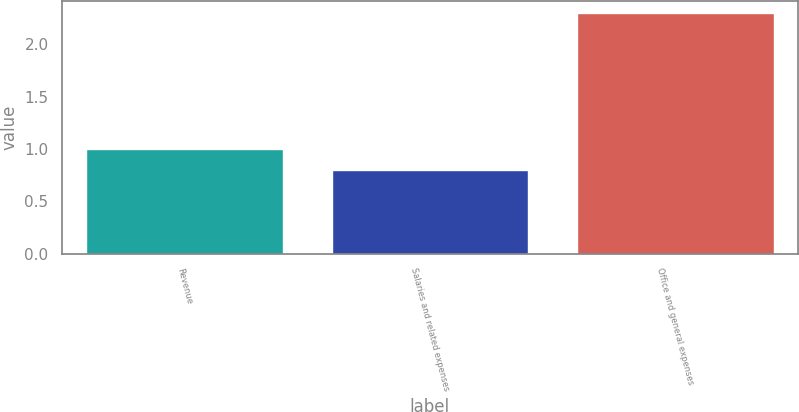<chart> <loc_0><loc_0><loc_500><loc_500><bar_chart><fcel>Revenue<fcel>Salaries and related expenses<fcel>Office and general expenses<nl><fcel>1<fcel>0.8<fcel>2.3<nl></chart> 